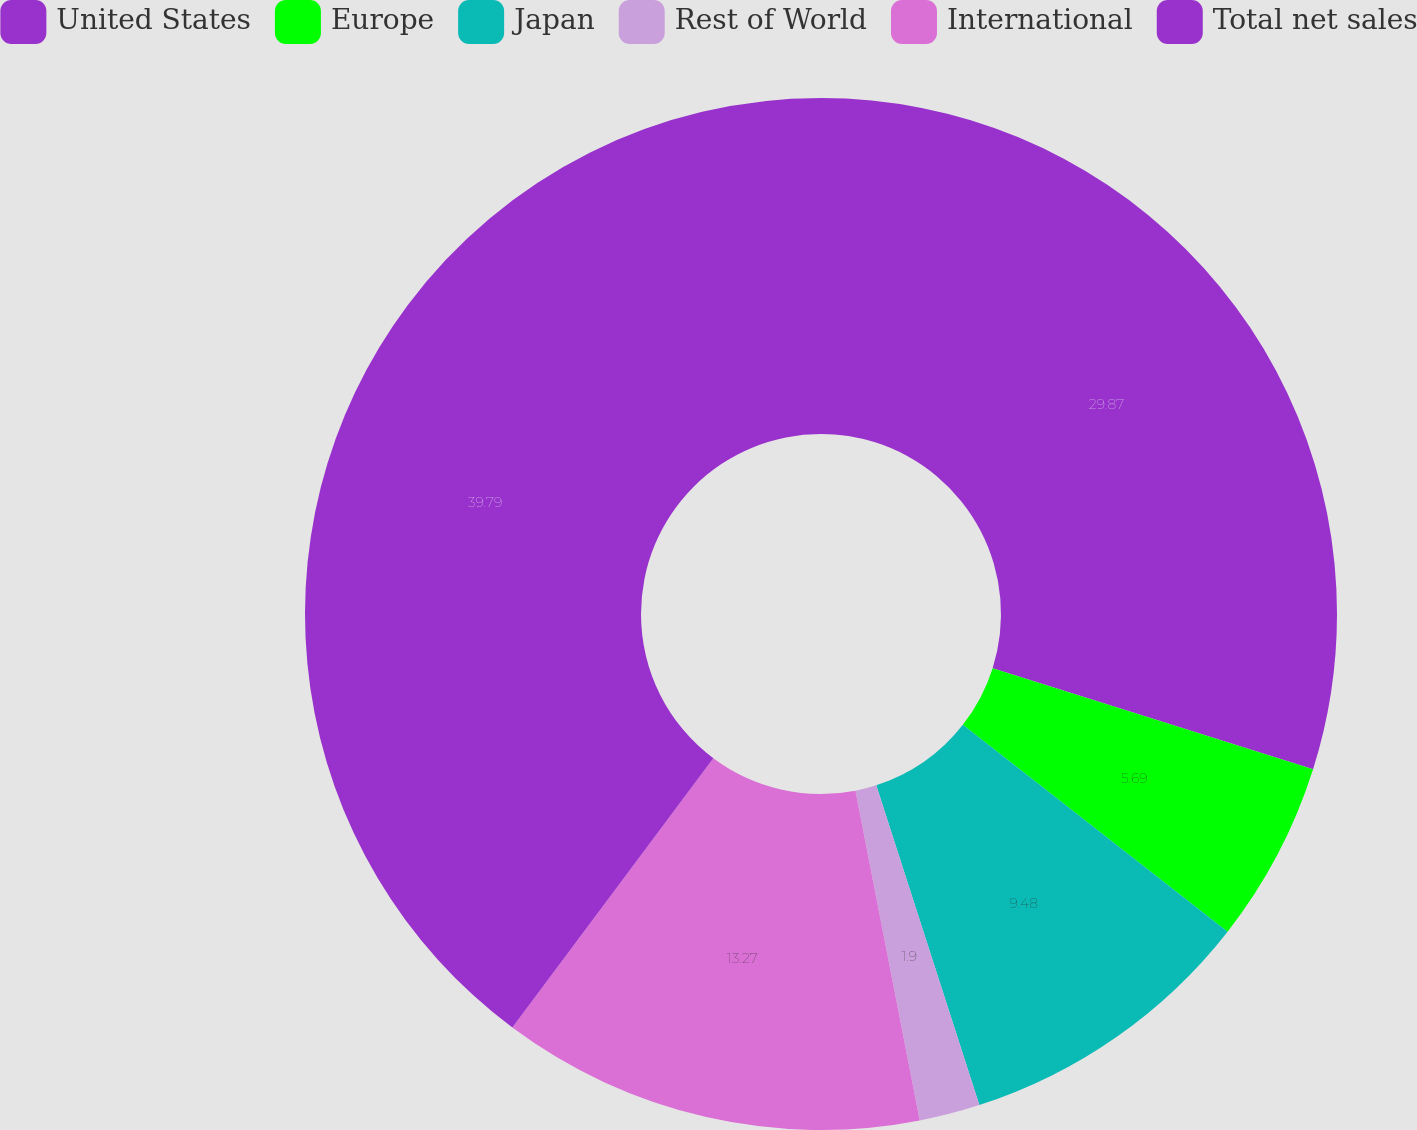<chart> <loc_0><loc_0><loc_500><loc_500><pie_chart><fcel>United States<fcel>Europe<fcel>Japan<fcel>Rest of World<fcel>International<fcel>Total net sales<nl><fcel>29.87%<fcel>5.69%<fcel>9.48%<fcel>1.9%<fcel>13.27%<fcel>39.8%<nl></chart> 